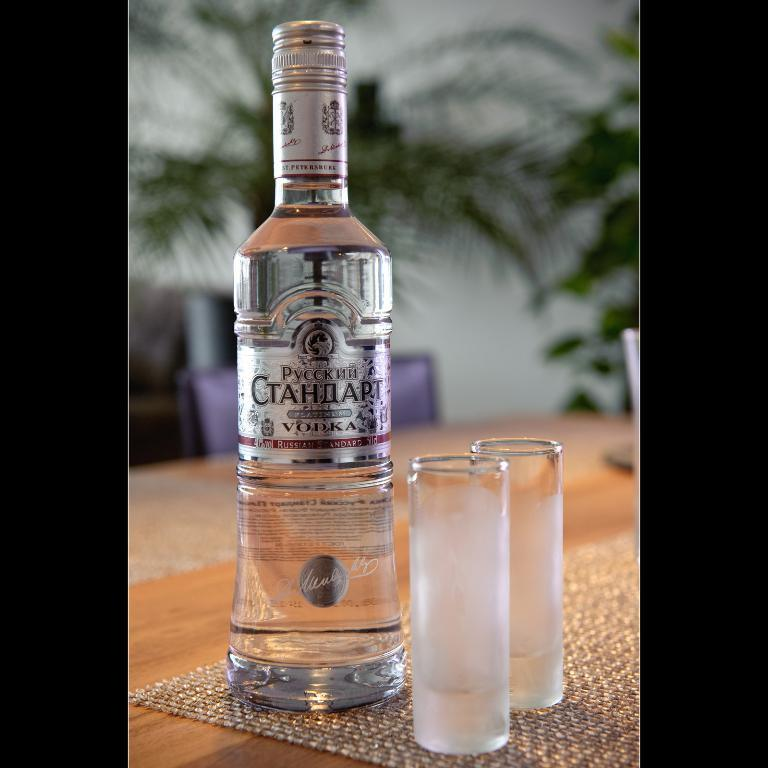<image>
Give a short and clear explanation of the subsequent image. A bottle of platinum vodka sits with two shot glasses. 